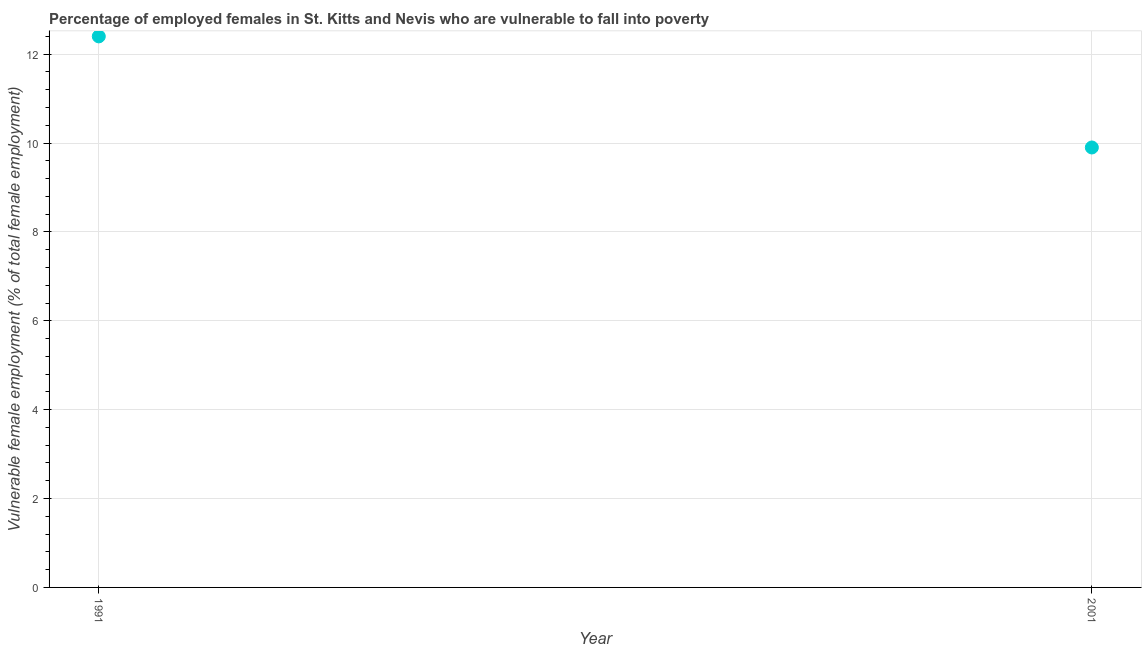What is the percentage of employed females who are vulnerable to fall into poverty in 2001?
Offer a very short reply. 9.9. Across all years, what is the maximum percentage of employed females who are vulnerable to fall into poverty?
Keep it short and to the point. 12.4. Across all years, what is the minimum percentage of employed females who are vulnerable to fall into poverty?
Your answer should be very brief. 9.9. In which year was the percentage of employed females who are vulnerable to fall into poverty maximum?
Offer a terse response. 1991. In which year was the percentage of employed females who are vulnerable to fall into poverty minimum?
Keep it short and to the point. 2001. What is the sum of the percentage of employed females who are vulnerable to fall into poverty?
Keep it short and to the point. 22.3. What is the difference between the percentage of employed females who are vulnerable to fall into poverty in 1991 and 2001?
Your answer should be very brief. 2.5. What is the average percentage of employed females who are vulnerable to fall into poverty per year?
Provide a succinct answer. 11.15. What is the median percentage of employed females who are vulnerable to fall into poverty?
Give a very brief answer. 11.15. In how many years, is the percentage of employed females who are vulnerable to fall into poverty greater than 9.2 %?
Your answer should be very brief. 2. Do a majority of the years between 2001 and 1991 (inclusive) have percentage of employed females who are vulnerable to fall into poverty greater than 3.6 %?
Offer a terse response. No. What is the ratio of the percentage of employed females who are vulnerable to fall into poverty in 1991 to that in 2001?
Provide a succinct answer. 1.25. Does the percentage of employed females who are vulnerable to fall into poverty monotonically increase over the years?
Offer a terse response. No. How many years are there in the graph?
Ensure brevity in your answer.  2. What is the difference between two consecutive major ticks on the Y-axis?
Make the answer very short. 2. Are the values on the major ticks of Y-axis written in scientific E-notation?
Your answer should be very brief. No. What is the title of the graph?
Ensure brevity in your answer.  Percentage of employed females in St. Kitts and Nevis who are vulnerable to fall into poverty. What is the label or title of the X-axis?
Provide a short and direct response. Year. What is the label or title of the Y-axis?
Ensure brevity in your answer.  Vulnerable female employment (% of total female employment). What is the Vulnerable female employment (% of total female employment) in 1991?
Give a very brief answer. 12.4. What is the Vulnerable female employment (% of total female employment) in 2001?
Keep it short and to the point. 9.9. What is the difference between the Vulnerable female employment (% of total female employment) in 1991 and 2001?
Your answer should be compact. 2.5. What is the ratio of the Vulnerable female employment (% of total female employment) in 1991 to that in 2001?
Give a very brief answer. 1.25. 